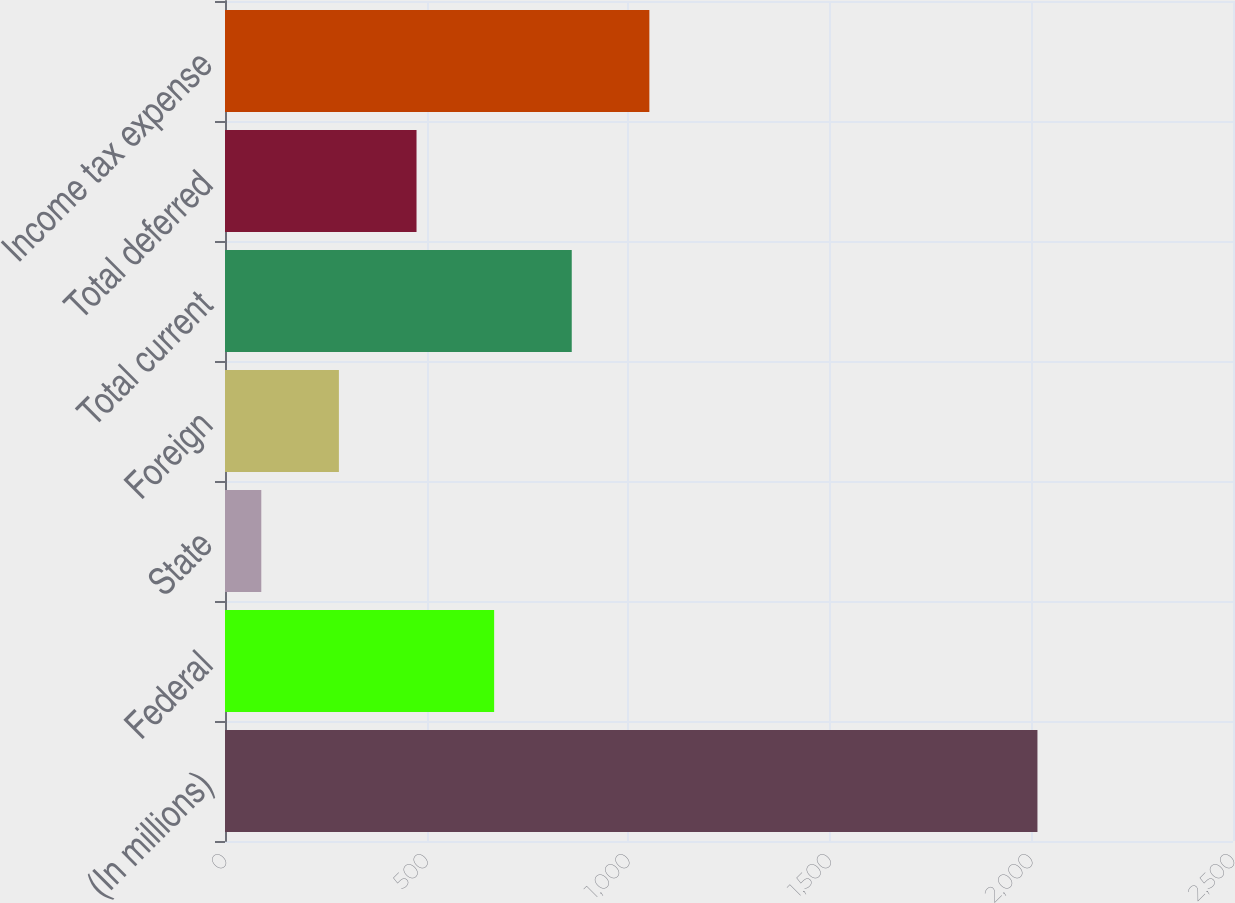Convert chart. <chart><loc_0><loc_0><loc_500><loc_500><bar_chart><fcel>(In millions)<fcel>Federal<fcel>State<fcel>Foreign<fcel>Total current<fcel>Total deferred<fcel>Income tax expense<nl><fcel>2015<fcel>667.5<fcel>90<fcel>282.5<fcel>860<fcel>475<fcel>1052.5<nl></chart> 